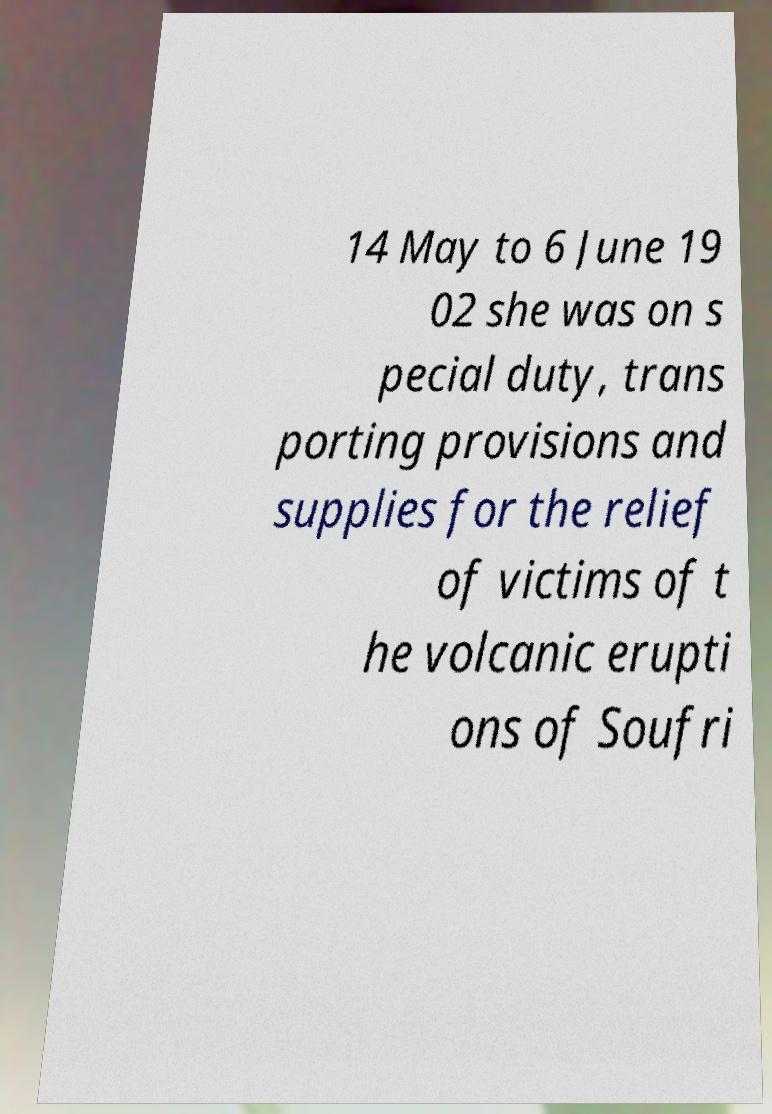Could you extract and type out the text from this image? 14 May to 6 June 19 02 she was on s pecial duty, trans porting provisions and supplies for the relief of victims of t he volcanic erupti ons of Soufri 